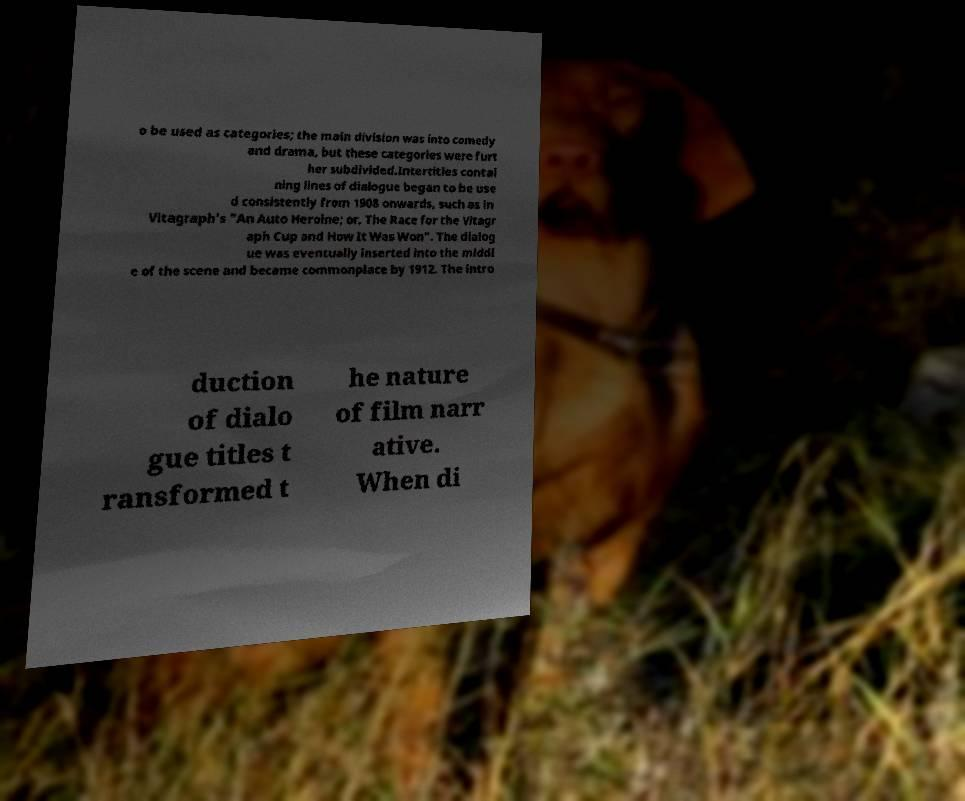I need the written content from this picture converted into text. Can you do that? o be used as categories; the main division was into comedy and drama, but these categories were furt her subdivided.Intertitles contai ning lines of dialogue began to be use d consistently from 1908 onwards, such as in Vitagraph's "An Auto Heroine; or, The Race for the Vitagr aph Cup and How It Was Won". The dialog ue was eventually inserted into the middl e of the scene and became commonplace by 1912. The intro duction of dialo gue titles t ransformed t he nature of film narr ative. When di 